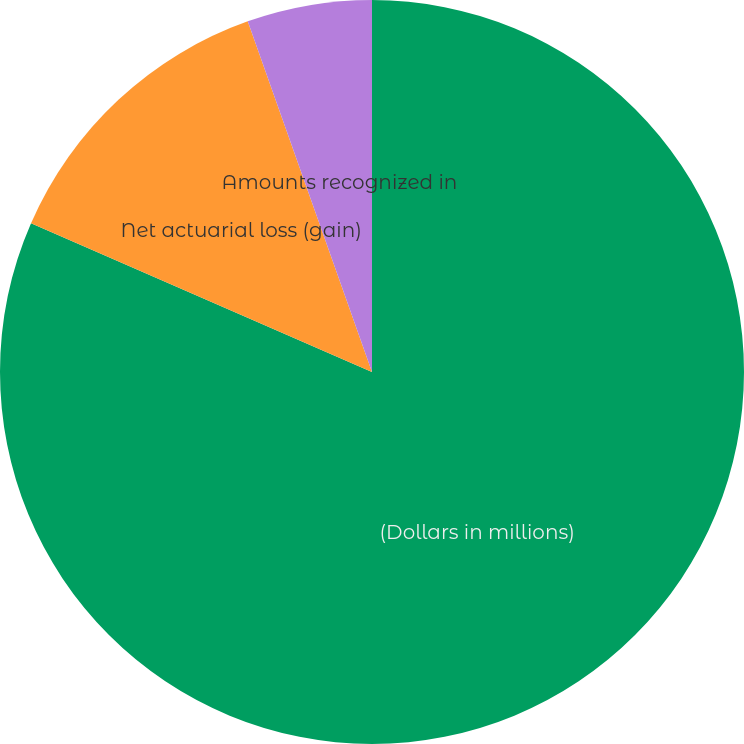Convert chart. <chart><loc_0><loc_0><loc_500><loc_500><pie_chart><fcel>(Dollars in millions)<fcel>Net actuarial loss (gain)<fcel>Amounts recognized in<nl><fcel>81.54%<fcel>13.03%<fcel>5.42%<nl></chart> 